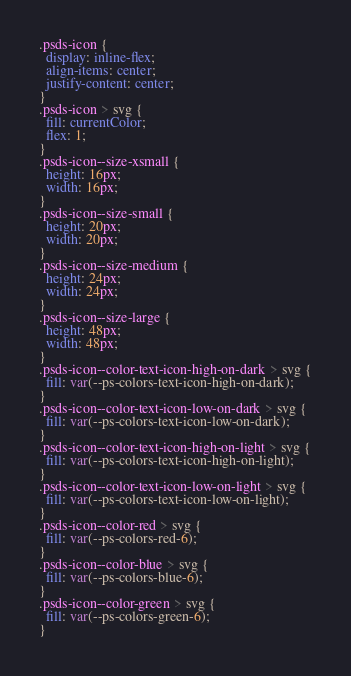<code> <loc_0><loc_0><loc_500><loc_500><_CSS_>.psds-icon {
  display: inline-flex;
  align-items: center;
  justify-content: center;
}
.psds-icon > svg {
  fill: currentColor;
  flex: 1;
}
.psds-icon--size-xsmall {
  height: 16px;
  width: 16px;
}
.psds-icon--size-small {
  height: 20px;
  width: 20px;
}
.psds-icon--size-medium {
  height: 24px;
  width: 24px;
}
.psds-icon--size-large {
  height: 48px;
  width: 48px;
}
.psds-icon--color-text-icon-high-on-dark > svg {
  fill: var(--ps-colors-text-icon-high-on-dark);
}
.psds-icon--color-text-icon-low-on-dark > svg {
  fill: var(--ps-colors-text-icon-low-on-dark);
}
.psds-icon--color-text-icon-high-on-light > svg {
  fill: var(--ps-colors-text-icon-high-on-light);
}
.psds-icon--color-text-icon-low-on-light > svg {
  fill: var(--ps-colors-text-icon-low-on-light);
}
.psds-icon--color-red > svg {
  fill: var(--ps-colors-red-6);
}
.psds-icon--color-blue > svg {
  fill: var(--ps-colors-blue-6);
}
.psds-icon--color-green > svg {
  fill: var(--ps-colors-green-6);
}</code> 